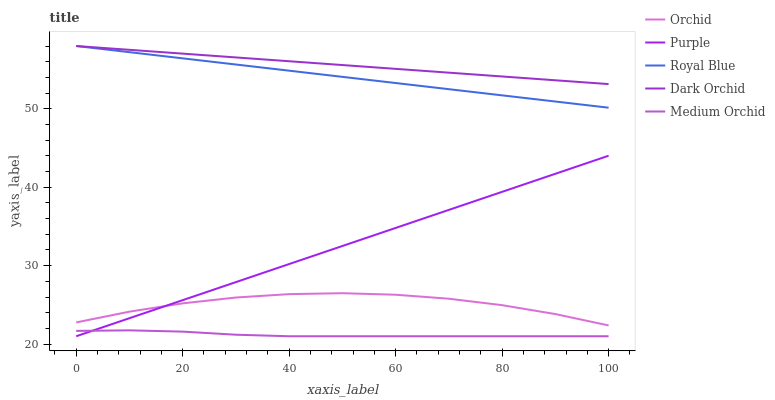Does Medium Orchid have the minimum area under the curve?
Answer yes or no. Yes. Does Dark Orchid have the maximum area under the curve?
Answer yes or no. Yes. Does Royal Blue have the minimum area under the curve?
Answer yes or no. No. Does Royal Blue have the maximum area under the curve?
Answer yes or no. No. Is Purple the smoothest?
Answer yes or no. Yes. Is Orchid the roughest?
Answer yes or no. Yes. Is Royal Blue the smoothest?
Answer yes or no. No. Is Royal Blue the roughest?
Answer yes or no. No. Does Royal Blue have the lowest value?
Answer yes or no. No. Does Dark Orchid have the highest value?
Answer yes or no. Yes. Does Medium Orchid have the highest value?
Answer yes or no. No. Is Medium Orchid less than Dark Orchid?
Answer yes or no. Yes. Is Royal Blue greater than Medium Orchid?
Answer yes or no. Yes. Does Purple intersect Medium Orchid?
Answer yes or no. Yes. Is Purple less than Medium Orchid?
Answer yes or no. No. Is Purple greater than Medium Orchid?
Answer yes or no. No. Does Medium Orchid intersect Dark Orchid?
Answer yes or no. No. 